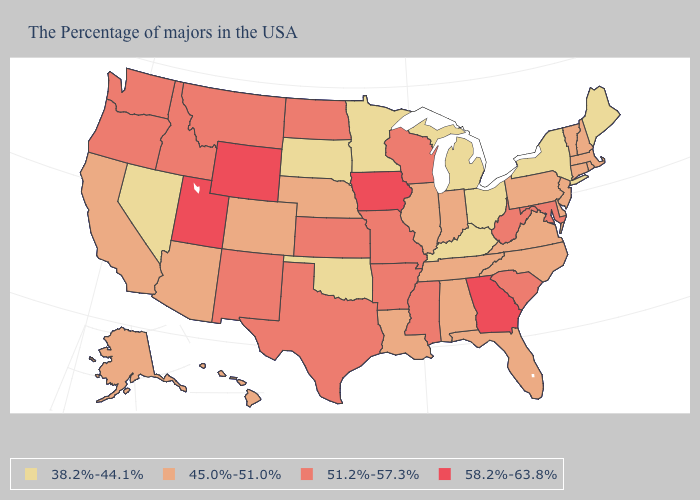Which states have the highest value in the USA?
Concise answer only. Georgia, Iowa, Wyoming, Utah. Name the states that have a value in the range 38.2%-44.1%?
Give a very brief answer. Maine, New York, Ohio, Michigan, Kentucky, Minnesota, Oklahoma, South Dakota, Nevada. Which states have the lowest value in the MidWest?
Be succinct. Ohio, Michigan, Minnesota, South Dakota. Among the states that border North Carolina , which have the highest value?
Give a very brief answer. Georgia. Name the states that have a value in the range 58.2%-63.8%?
Quick response, please. Georgia, Iowa, Wyoming, Utah. How many symbols are there in the legend?
Short answer required. 4. Is the legend a continuous bar?
Quick response, please. No. Among the states that border Mississippi , does Arkansas have the lowest value?
Give a very brief answer. No. What is the highest value in the Northeast ?
Quick response, please. 45.0%-51.0%. What is the value of Texas?
Give a very brief answer. 51.2%-57.3%. What is the value of Colorado?
Short answer required. 45.0%-51.0%. What is the lowest value in the South?
Keep it brief. 38.2%-44.1%. Among the states that border Maryland , does Virginia have the highest value?
Quick response, please. No. Name the states that have a value in the range 45.0%-51.0%?
Keep it brief. Massachusetts, Rhode Island, New Hampshire, Vermont, Connecticut, New Jersey, Delaware, Pennsylvania, Virginia, North Carolina, Florida, Indiana, Alabama, Tennessee, Illinois, Louisiana, Nebraska, Colorado, Arizona, California, Alaska, Hawaii. Among the states that border Kansas , does Colorado have the lowest value?
Keep it brief. No. 